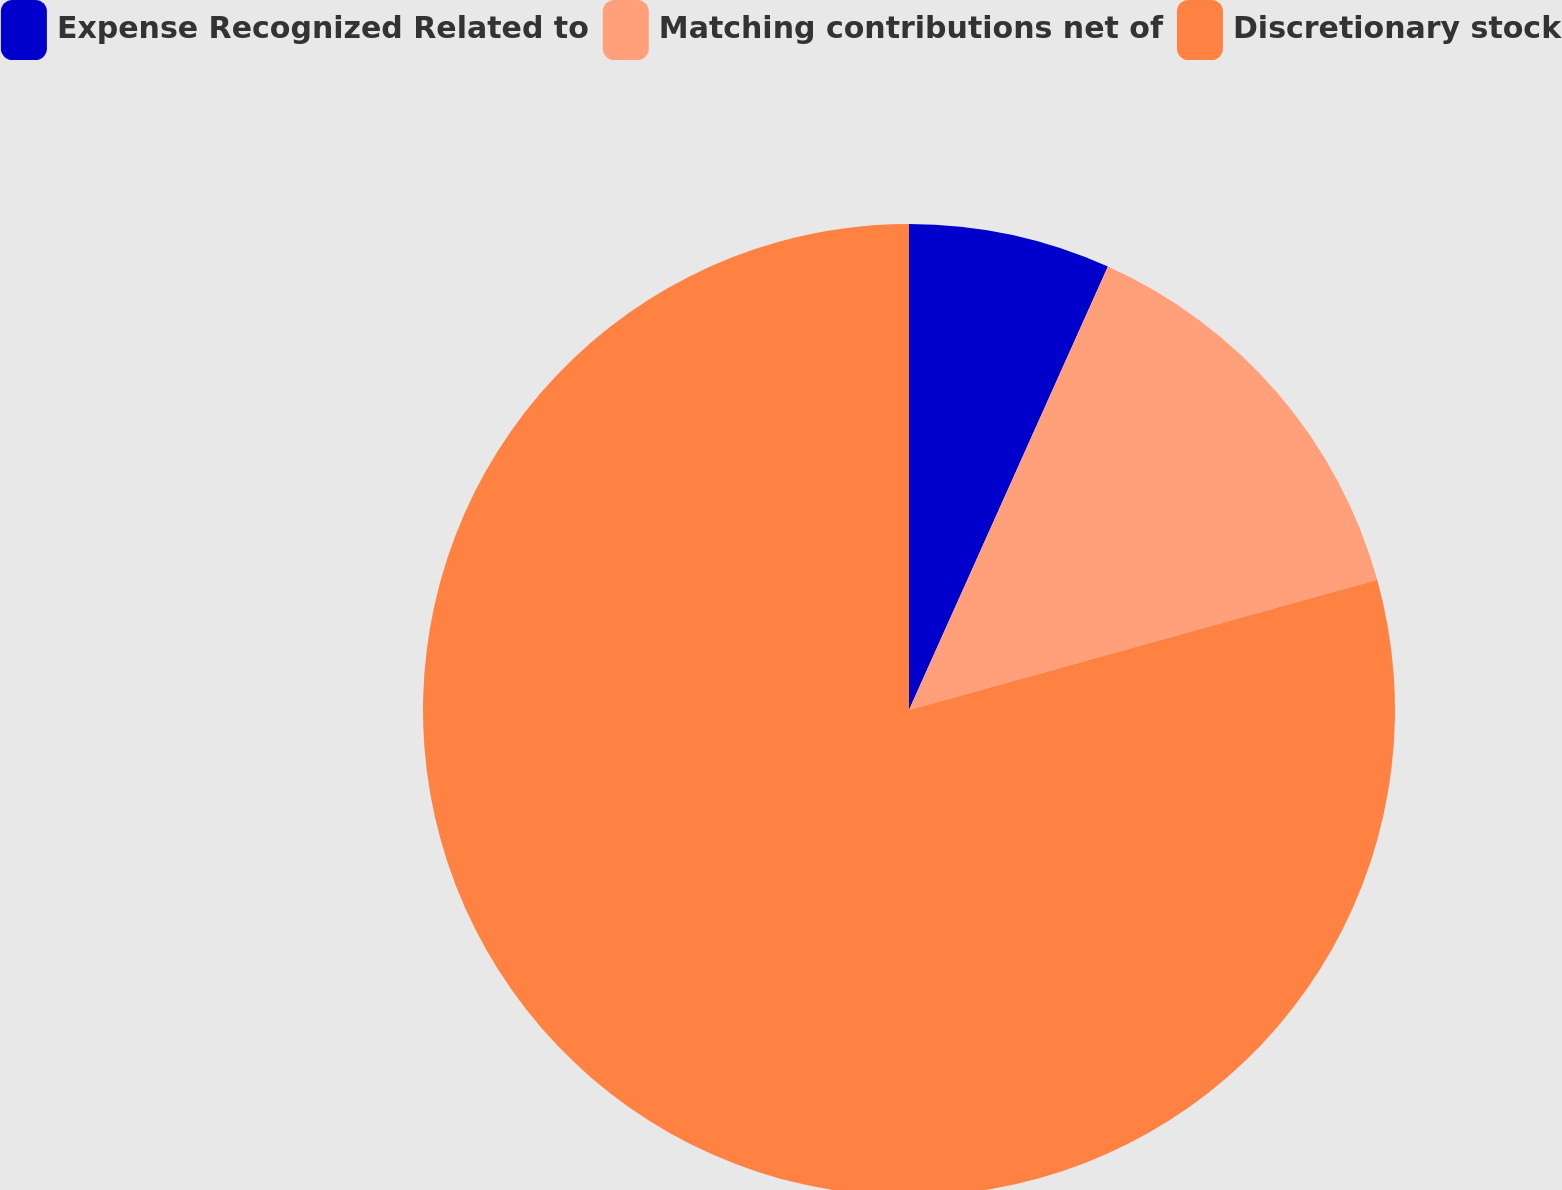Convert chart to OTSL. <chart><loc_0><loc_0><loc_500><loc_500><pie_chart><fcel>Expense Recognized Related to<fcel>Matching contributions net of<fcel>Discretionary stock<nl><fcel>6.71%<fcel>13.97%<fcel>79.31%<nl></chart> 